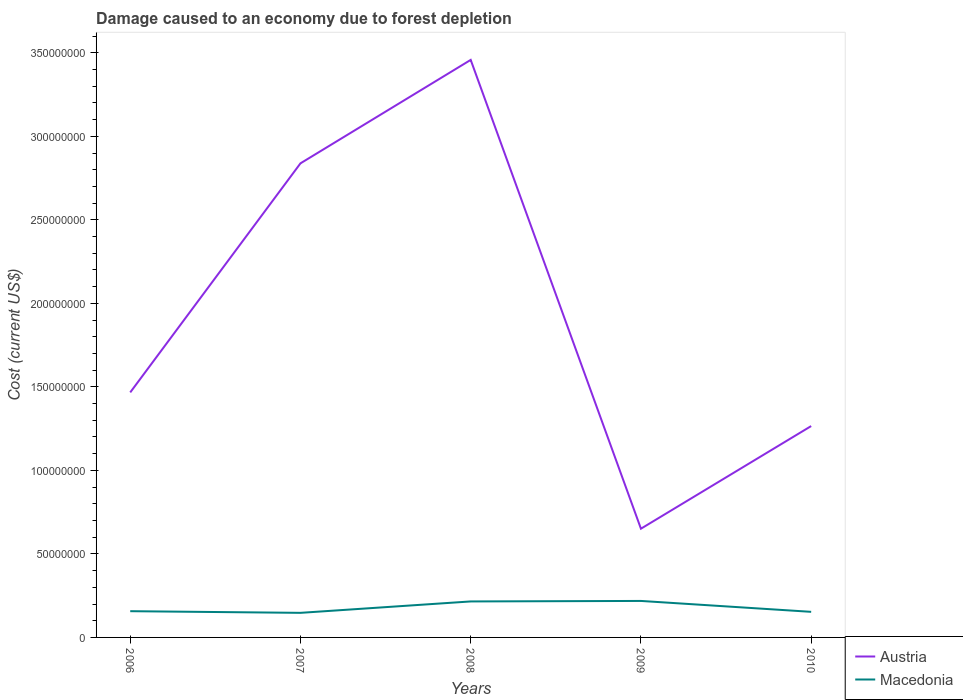How many different coloured lines are there?
Offer a terse response. 2. Does the line corresponding to Austria intersect with the line corresponding to Macedonia?
Your answer should be compact. No. Across all years, what is the maximum cost of damage caused due to forest depletion in Austria?
Offer a terse response. 6.51e+07. In which year was the cost of damage caused due to forest depletion in Macedonia maximum?
Provide a succinct answer. 2007. What is the total cost of damage caused due to forest depletion in Macedonia in the graph?
Ensure brevity in your answer.  -6.01e+05. What is the difference between the highest and the second highest cost of damage caused due to forest depletion in Macedonia?
Keep it short and to the point. 7.13e+06. What is the difference between the highest and the lowest cost of damage caused due to forest depletion in Austria?
Give a very brief answer. 2. How many years are there in the graph?
Give a very brief answer. 5. What is the difference between two consecutive major ticks on the Y-axis?
Your answer should be very brief. 5.00e+07. Are the values on the major ticks of Y-axis written in scientific E-notation?
Offer a terse response. No. Where does the legend appear in the graph?
Offer a terse response. Bottom right. What is the title of the graph?
Your answer should be very brief. Damage caused to an economy due to forest depletion. What is the label or title of the Y-axis?
Your answer should be compact. Cost (current US$). What is the Cost (current US$) of Austria in 2006?
Provide a short and direct response. 1.47e+08. What is the Cost (current US$) in Macedonia in 2006?
Ensure brevity in your answer.  1.57e+07. What is the Cost (current US$) in Austria in 2007?
Your response must be concise. 2.84e+08. What is the Cost (current US$) of Macedonia in 2007?
Provide a succinct answer. 1.47e+07. What is the Cost (current US$) in Austria in 2008?
Offer a terse response. 3.46e+08. What is the Cost (current US$) in Macedonia in 2008?
Keep it short and to the point. 2.15e+07. What is the Cost (current US$) of Austria in 2009?
Make the answer very short. 6.51e+07. What is the Cost (current US$) in Macedonia in 2009?
Provide a succinct answer. 2.18e+07. What is the Cost (current US$) of Austria in 2010?
Ensure brevity in your answer.  1.27e+08. What is the Cost (current US$) of Macedonia in 2010?
Make the answer very short. 1.53e+07. Across all years, what is the maximum Cost (current US$) in Austria?
Make the answer very short. 3.46e+08. Across all years, what is the maximum Cost (current US$) of Macedonia?
Your answer should be very brief. 2.18e+07. Across all years, what is the minimum Cost (current US$) in Austria?
Keep it short and to the point. 6.51e+07. Across all years, what is the minimum Cost (current US$) in Macedonia?
Keep it short and to the point. 1.47e+07. What is the total Cost (current US$) of Austria in the graph?
Make the answer very short. 9.68e+08. What is the total Cost (current US$) in Macedonia in the graph?
Offer a terse response. 8.91e+07. What is the difference between the Cost (current US$) in Austria in 2006 and that in 2007?
Ensure brevity in your answer.  -1.37e+08. What is the difference between the Cost (current US$) of Macedonia in 2006 and that in 2007?
Offer a terse response. 9.89e+05. What is the difference between the Cost (current US$) of Austria in 2006 and that in 2008?
Keep it short and to the point. -1.99e+08. What is the difference between the Cost (current US$) in Macedonia in 2006 and that in 2008?
Give a very brief answer. -5.84e+06. What is the difference between the Cost (current US$) in Austria in 2006 and that in 2009?
Make the answer very short. 8.16e+07. What is the difference between the Cost (current US$) in Macedonia in 2006 and that in 2009?
Keep it short and to the point. -6.14e+06. What is the difference between the Cost (current US$) in Austria in 2006 and that in 2010?
Your answer should be very brief. 2.02e+07. What is the difference between the Cost (current US$) in Macedonia in 2006 and that in 2010?
Give a very brief answer. 3.88e+05. What is the difference between the Cost (current US$) in Austria in 2007 and that in 2008?
Offer a very short reply. -6.19e+07. What is the difference between the Cost (current US$) in Macedonia in 2007 and that in 2008?
Your answer should be compact. -6.83e+06. What is the difference between the Cost (current US$) of Austria in 2007 and that in 2009?
Offer a terse response. 2.19e+08. What is the difference between the Cost (current US$) in Macedonia in 2007 and that in 2009?
Offer a very short reply. -7.13e+06. What is the difference between the Cost (current US$) in Austria in 2007 and that in 2010?
Provide a succinct answer. 1.57e+08. What is the difference between the Cost (current US$) in Macedonia in 2007 and that in 2010?
Offer a very short reply. -6.01e+05. What is the difference between the Cost (current US$) of Austria in 2008 and that in 2009?
Your answer should be compact. 2.81e+08. What is the difference between the Cost (current US$) in Macedonia in 2008 and that in 2009?
Provide a short and direct response. -3.02e+05. What is the difference between the Cost (current US$) in Austria in 2008 and that in 2010?
Provide a short and direct response. 2.19e+08. What is the difference between the Cost (current US$) in Macedonia in 2008 and that in 2010?
Offer a very short reply. 6.22e+06. What is the difference between the Cost (current US$) of Austria in 2009 and that in 2010?
Give a very brief answer. -6.14e+07. What is the difference between the Cost (current US$) of Macedonia in 2009 and that in 2010?
Keep it short and to the point. 6.53e+06. What is the difference between the Cost (current US$) of Austria in 2006 and the Cost (current US$) of Macedonia in 2007?
Offer a terse response. 1.32e+08. What is the difference between the Cost (current US$) in Austria in 2006 and the Cost (current US$) in Macedonia in 2008?
Your answer should be compact. 1.25e+08. What is the difference between the Cost (current US$) of Austria in 2006 and the Cost (current US$) of Macedonia in 2009?
Offer a very short reply. 1.25e+08. What is the difference between the Cost (current US$) in Austria in 2006 and the Cost (current US$) in Macedonia in 2010?
Offer a very short reply. 1.31e+08. What is the difference between the Cost (current US$) of Austria in 2007 and the Cost (current US$) of Macedonia in 2008?
Your response must be concise. 2.62e+08. What is the difference between the Cost (current US$) in Austria in 2007 and the Cost (current US$) in Macedonia in 2009?
Make the answer very short. 2.62e+08. What is the difference between the Cost (current US$) of Austria in 2007 and the Cost (current US$) of Macedonia in 2010?
Provide a short and direct response. 2.68e+08. What is the difference between the Cost (current US$) in Austria in 2008 and the Cost (current US$) in Macedonia in 2009?
Your response must be concise. 3.24e+08. What is the difference between the Cost (current US$) in Austria in 2008 and the Cost (current US$) in Macedonia in 2010?
Offer a terse response. 3.30e+08. What is the difference between the Cost (current US$) in Austria in 2009 and the Cost (current US$) in Macedonia in 2010?
Your answer should be compact. 4.98e+07. What is the average Cost (current US$) of Austria per year?
Provide a short and direct response. 1.94e+08. What is the average Cost (current US$) in Macedonia per year?
Make the answer very short. 1.78e+07. In the year 2006, what is the difference between the Cost (current US$) of Austria and Cost (current US$) of Macedonia?
Your answer should be very brief. 1.31e+08. In the year 2007, what is the difference between the Cost (current US$) in Austria and Cost (current US$) in Macedonia?
Your answer should be compact. 2.69e+08. In the year 2008, what is the difference between the Cost (current US$) in Austria and Cost (current US$) in Macedonia?
Ensure brevity in your answer.  3.24e+08. In the year 2009, what is the difference between the Cost (current US$) in Austria and Cost (current US$) in Macedonia?
Your answer should be very brief. 4.32e+07. In the year 2010, what is the difference between the Cost (current US$) in Austria and Cost (current US$) in Macedonia?
Offer a very short reply. 1.11e+08. What is the ratio of the Cost (current US$) in Austria in 2006 to that in 2007?
Your answer should be compact. 0.52. What is the ratio of the Cost (current US$) in Macedonia in 2006 to that in 2007?
Offer a terse response. 1.07. What is the ratio of the Cost (current US$) in Austria in 2006 to that in 2008?
Your answer should be very brief. 0.42. What is the ratio of the Cost (current US$) of Macedonia in 2006 to that in 2008?
Your response must be concise. 0.73. What is the ratio of the Cost (current US$) of Austria in 2006 to that in 2009?
Your answer should be very brief. 2.25. What is the ratio of the Cost (current US$) in Macedonia in 2006 to that in 2009?
Offer a very short reply. 0.72. What is the ratio of the Cost (current US$) in Austria in 2006 to that in 2010?
Ensure brevity in your answer.  1.16. What is the ratio of the Cost (current US$) of Macedonia in 2006 to that in 2010?
Your answer should be very brief. 1.03. What is the ratio of the Cost (current US$) in Austria in 2007 to that in 2008?
Your answer should be compact. 0.82. What is the ratio of the Cost (current US$) of Macedonia in 2007 to that in 2008?
Make the answer very short. 0.68. What is the ratio of the Cost (current US$) of Austria in 2007 to that in 2009?
Make the answer very short. 4.36. What is the ratio of the Cost (current US$) in Macedonia in 2007 to that in 2009?
Make the answer very short. 0.67. What is the ratio of the Cost (current US$) in Austria in 2007 to that in 2010?
Provide a succinct answer. 2.24. What is the ratio of the Cost (current US$) in Macedonia in 2007 to that in 2010?
Offer a terse response. 0.96. What is the ratio of the Cost (current US$) in Austria in 2008 to that in 2009?
Your response must be concise. 5.31. What is the ratio of the Cost (current US$) in Macedonia in 2008 to that in 2009?
Provide a short and direct response. 0.99. What is the ratio of the Cost (current US$) in Austria in 2008 to that in 2010?
Offer a terse response. 2.73. What is the ratio of the Cost (current US$) in Macedonia in 2008 to that in 2010?
Your answer should be compact. 1.41. What is the ratio of the Cost (current US$) of Austria in 2009 to that in 2010?
Ensure brevity in your answer.  0.51. What is the ratio of the Cost (current US$) of Macedonia in 2009 to that in 2010?
Your response must be concise. 1.43. What is the difference between the highest and the second highest Cost (current US$) of Austria?
Provide a short and direct response. 6.19e+07. What is the difference between the highest and the second highest Cost (current US$) of Macedonia?
Ensure brevity in your answer.  3.02e+05. What is the difference between the highest and the lowest Cost (current US$) in Austria?
Your answer should be very brief. 2.81e+08. What is the difference between the highest and the lowest Cost (current US$) in Macedonia?
Give a very brief answer. 7.13e+06. 